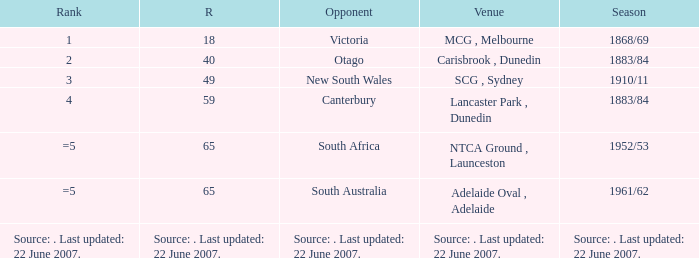Which Runs has a Opponent of south australia? 65.0. 